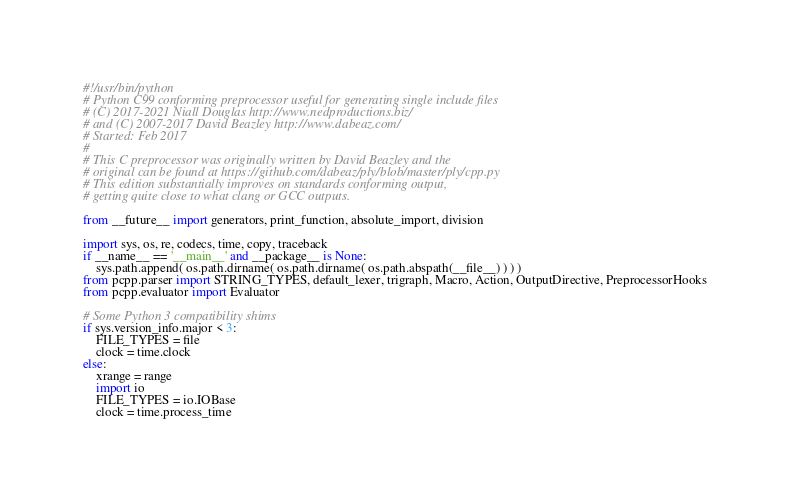<code> <loc_0><loc_0><loc_500><loc_500><_Python_>#!/usr/bin/python
# Python C99 conforming preprocessor useful for generating single include files
# (C) 2017-2021 Niall Douglas http://www.nedproductions.biz/
# and (C) 2007-2017 David Beazley http://www.dabeaz.com/
# Started: Feb 2017
#
# This C preprocessor was originally written by David Beazley and the
# original can be found at https://github.com/dabeaz/ply/blob/master/ply/cpp.py
# This edition substantially improves on standards conforming output,
# getting quite close to what clang or GCC outputs.

from __future__ import generators, print_function, absolute_import, division

import sys, os, re, codecs, time, copy, traceback
if __name__ == '__main__' and __package__ is None:
    sys.path.append( os.path.dirname( os.path.dirname( os.path.abspath(__file__) ) ) )
from pcpp.parser import STRING_TYPES, default_lexer, trigraph, Macro, Action, OutputDirective, PreprocessorHooks
from pcpp.evaluator import Evaluator

# Some Python 3 compatibility shims
if sys.version_info.major < 3:
    FILE_TYPES = file
    clock = time.clock
else:
    xrange = range
    import io
    FILE_TYPES = io.IOBase
    clock = time.process_time
</code> 